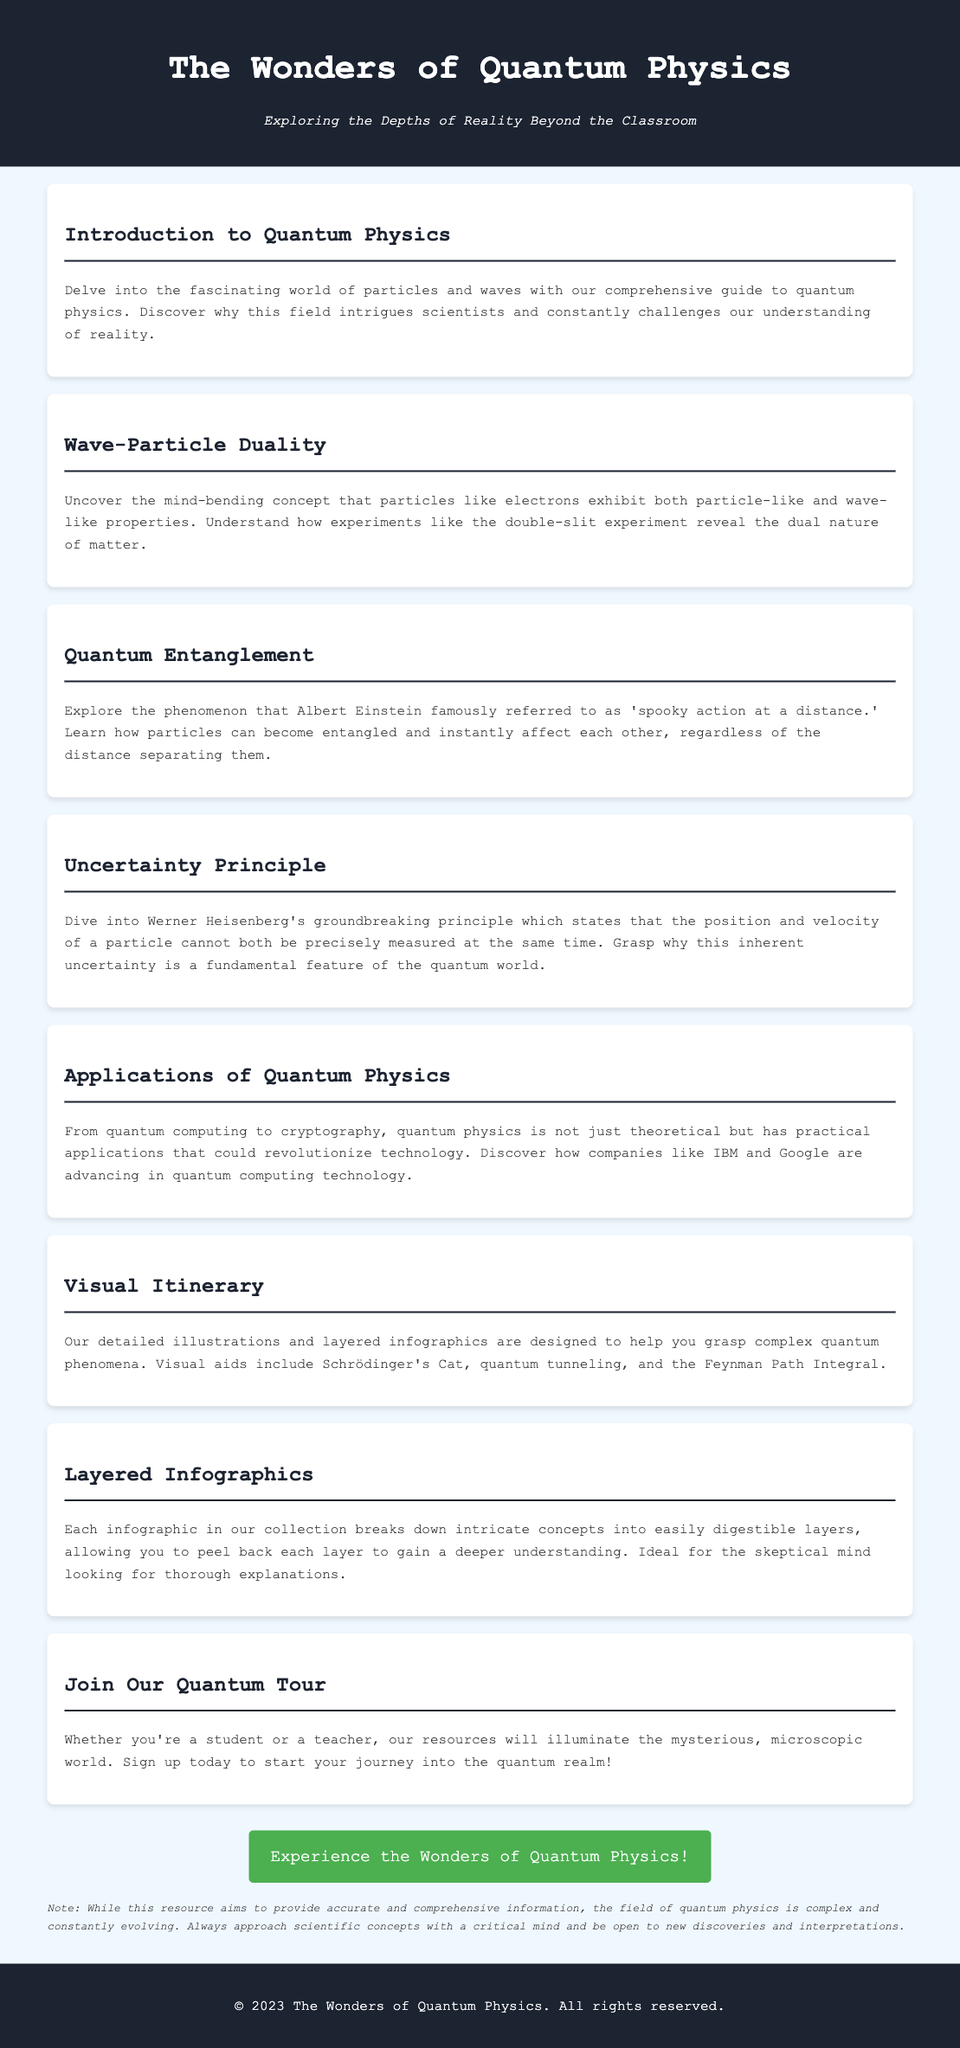What is the title of the advertisement? The title of the advertisement is prominently stated at the top of the document.
Answer: The Wonders of Quantum Physics What phenomenon does Einstein refer to as 'spooky action at a distance'? This refers to a specific concept discussed in the advertisement, highlighting its intriguing nature.
Answer: Quantum Entanglement Which principle states that both position and velocity of a particle cannot be precisely measured at the same time? This principle is a key concept addressed in the document, indicating its significance in quantum physics.
Answer: Uncertainty Principle What type of aids are used to help understand complex quantum phenomena? This information specifies the tools utilized for visual explanation in the advertisement.
Answer: Detailed illustrations and layered infographics What is the main focus of the section titled "Applications of Quantum Physics"? This section emphasizes the real-world implications of the theoretical concepts discussed previously.
Answer: Practical applications that could revolutionize technology What is the target audience for the "Join Our Quantum Tour" section? This question identifies who the advertisement is designed to engage and recruit.
Answer: Students and teachers What does the disclaimer encourage regarding scientific concepts? Understanding this statement reflects the document's aim to promote critical thinking about the content presented.
Answer: Approach with a critical mind How many sections are there in the document? Counting the sections gives insight into the organization and coverage of topics in the advertisement.
Answer: Eight sections 